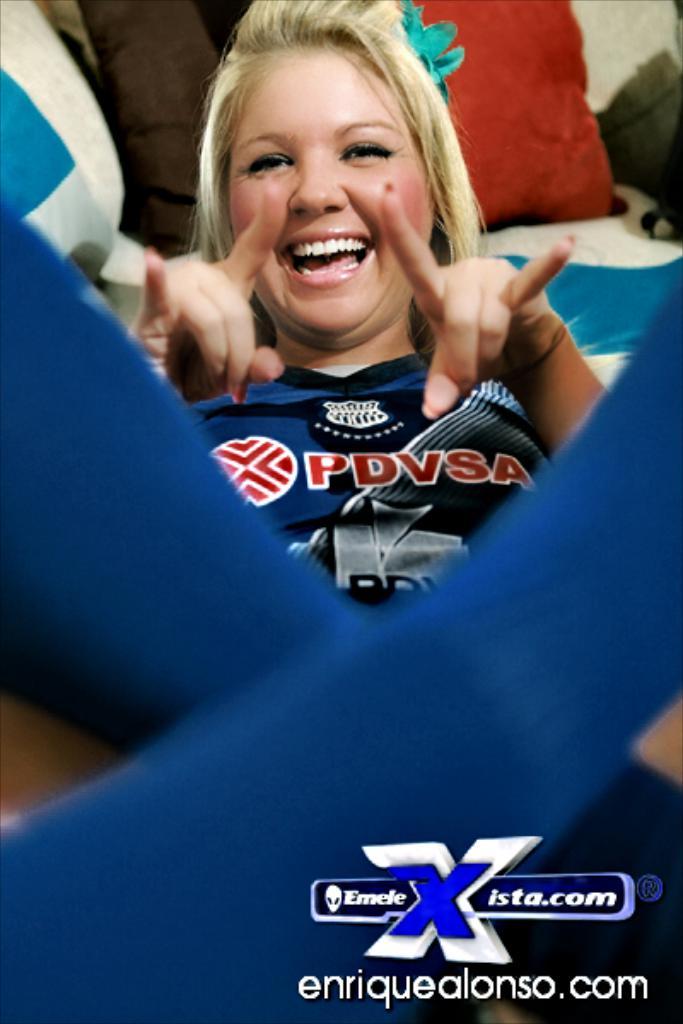What website is listed?
Offer a very short reply. Enriquealonso.com. 